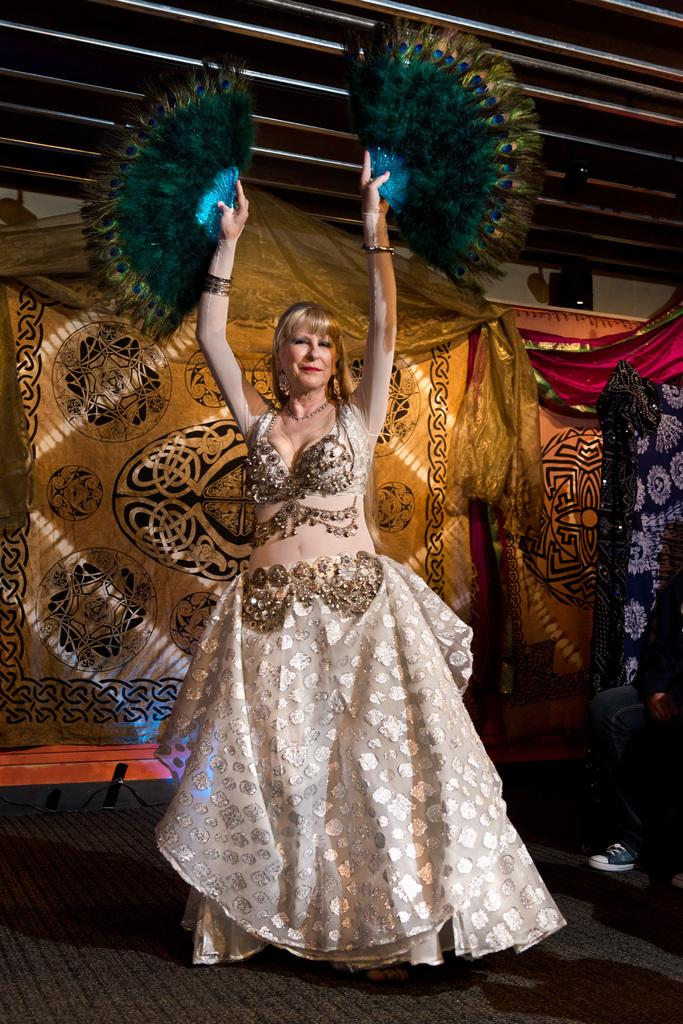What is the main subject of the image? The main subject of the image is a woman. What is the woman wearing? The woman is wearing a gown. What is the woman holding in her hands? The woman is holding feather fans. What type of dance is the woman performing? The woman is doing belly dance. Where is the woman positioned in the image? The woman is on the floor. What can be seen in the background of the image? There are curtains in the background of the image. What type of quiver can be seen on the woman's back in the image? There is no quiver present on the woman's back in the image. How does the harmony of the music affect the woman's dance performance in the image? The image does not provide any information about the music or its harmony, so we cannot determine its effect on the woman's dance performance. 